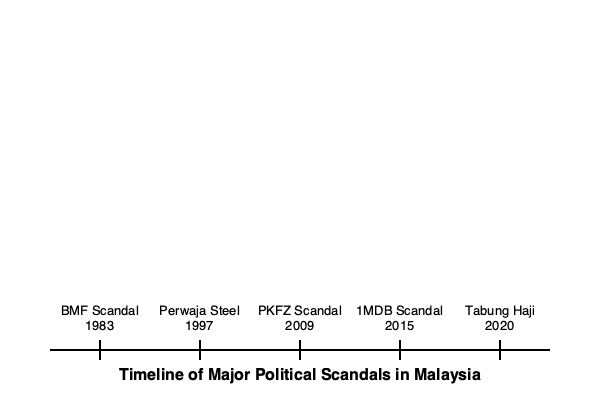Based on the timeline of major political scandals in Malaysia's history, which scandal occurred closest to the Asian Financial Crisis of 1997-1998? To answer this question, we need to follow these steps:

1. Identify the year of the Asian Financial Crisis: 1997-1998

2. List the scandals and their years from the timeline:
   - BMF Scandal: 1983
   - Perwaja Steel: 1997
   - PKFZ Scandal: 2009
   - 1MDB Scandal: 2015
   - Tabung Haji: 2020

3. Compare each scandal's year to 1997-1998:
   - BMF Scandal: 14-15 years before
   - Perwaja Steel: Occurred in 1997, coinciding with the crisis
   - PKFZ Scandal: 11-12 years after
   - 1MDB Scandal: 17-18 years after
   - Tabung Haji: 22-23 years after

4. Determine which scandal is closest in time to the Asian Financial Crisis:
   The Perwaja Steel scandal in 1997 occurred in the same year as the beginning of the Asian Financial Crisis, making it the closest in time.
Answer: Perwaja Steel scandal (1997) 